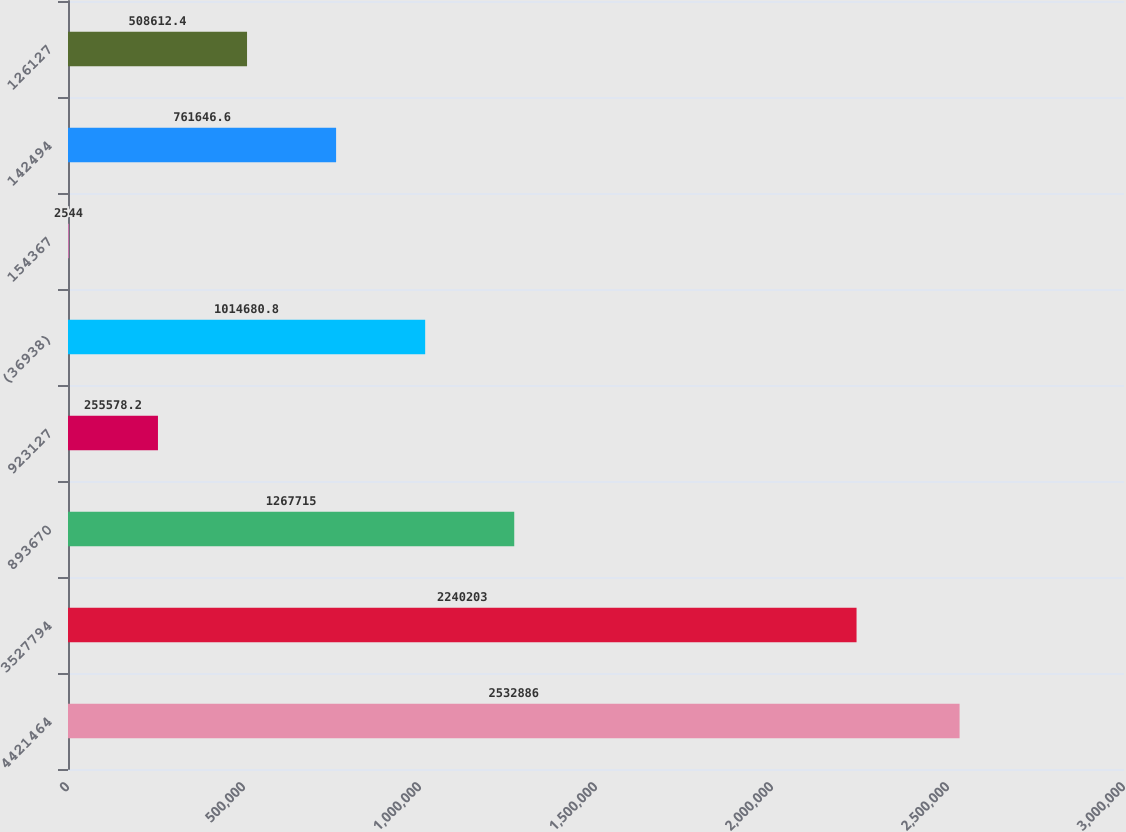Convert chart. <chart><loc_0><loc_0><loc_500><loc_500><bar_chart><fcel>4421464<fcel>3527794<fcel>893670<fcel>923127<fcel>(36938)<fcel>154367<fcel>142494<fcel>126127<nl><fcel>2.53289e+06<fcel>2.2402e+06<fcel>1.26772e+06<fcel>255578<fcel>1.01468e+06<fcel>2544<fcel>761647<fcel>508612<nl></chart> 